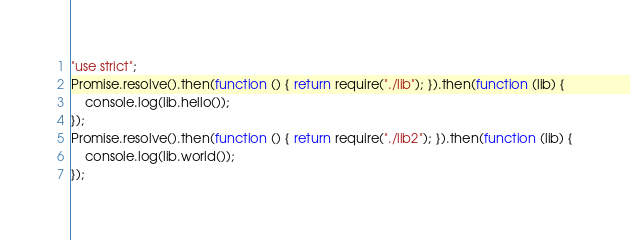Convert code to text. <code><loc_0><loc_0><loc_500><loc_500><_JavaScript_>"use strict";
Promise.resolve().then(function () { return require("./lib"); }).then(function (lib) {
    console.log(lib.hello());
});
Promise.resolve().then(function () { return require("./lib2"); }).then(function (lib) {
    console.log(lib.world());
});
</code> 